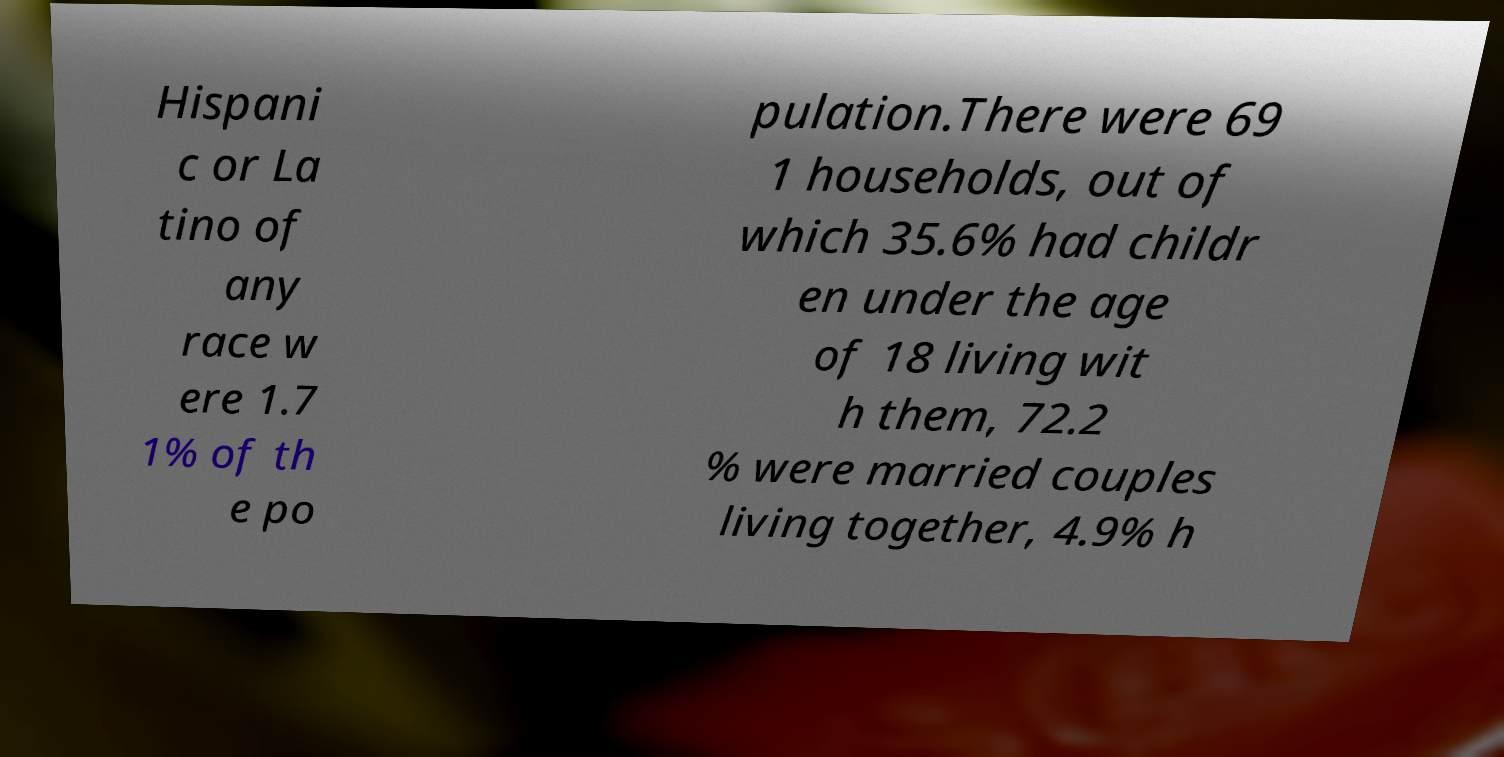Please read and relay the text visible in this image. What does it say? Hispani c or La tino of any race w ere 1.7 1% of th e po pulation.There were 69 1 households, out of which 35.6% had childr en under the age of 18 living wit h them, 72.2 % were married couples living together, 4.9% h 